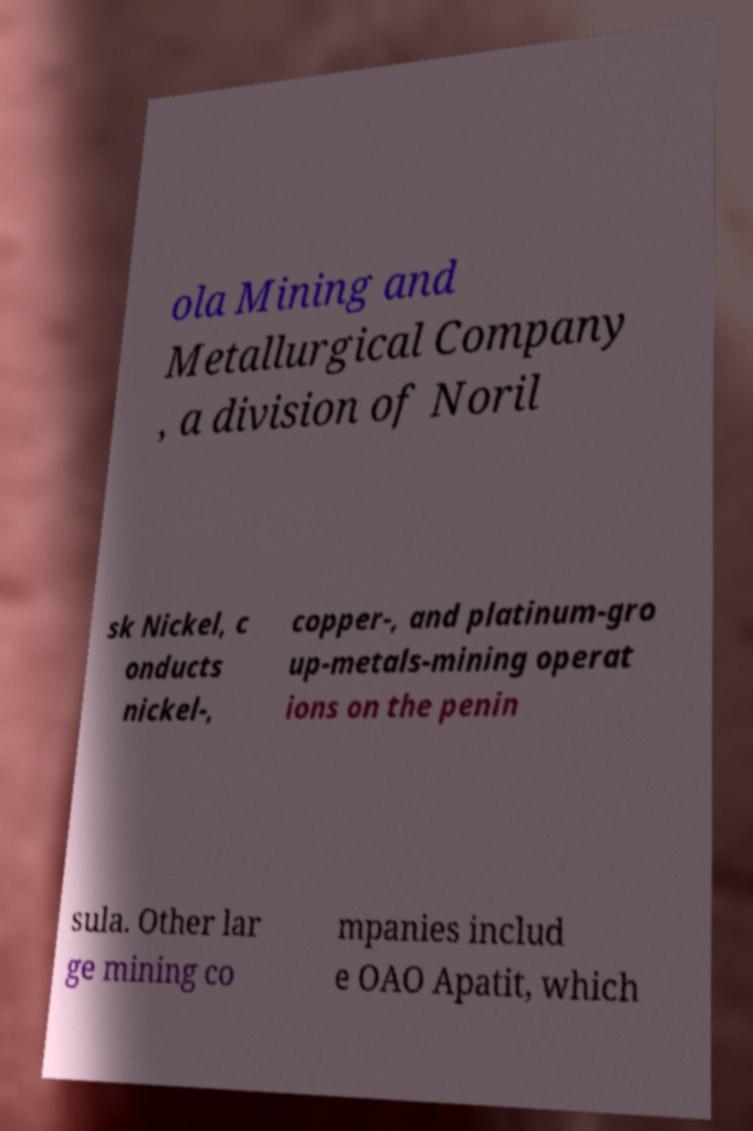What messages or text are displayed in this image? I need them in a readable, typed format. ola Mining and Metallurgical Company , a division of Noril sk Nickel, c onducts nickel-, copper-, and platinum-gro up-metals-mining operat ions on the penin sula. Other lar ge mining co mpanies includ e OAO Apatit, which 